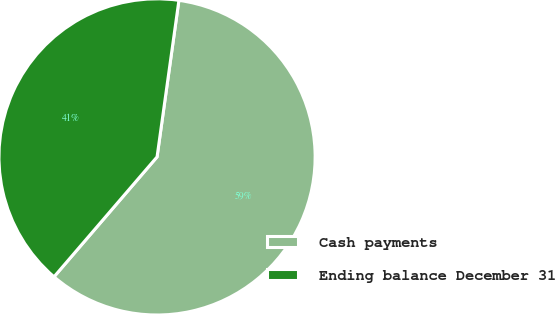Convert chart. <chart><loc_0><loc_0><loc_500><loc_500><pie_chart><fcel>Cash payments<fcel>Ending balance December 31<nl><fcel>59.09%<fcel>40.91%<nl></chart> 